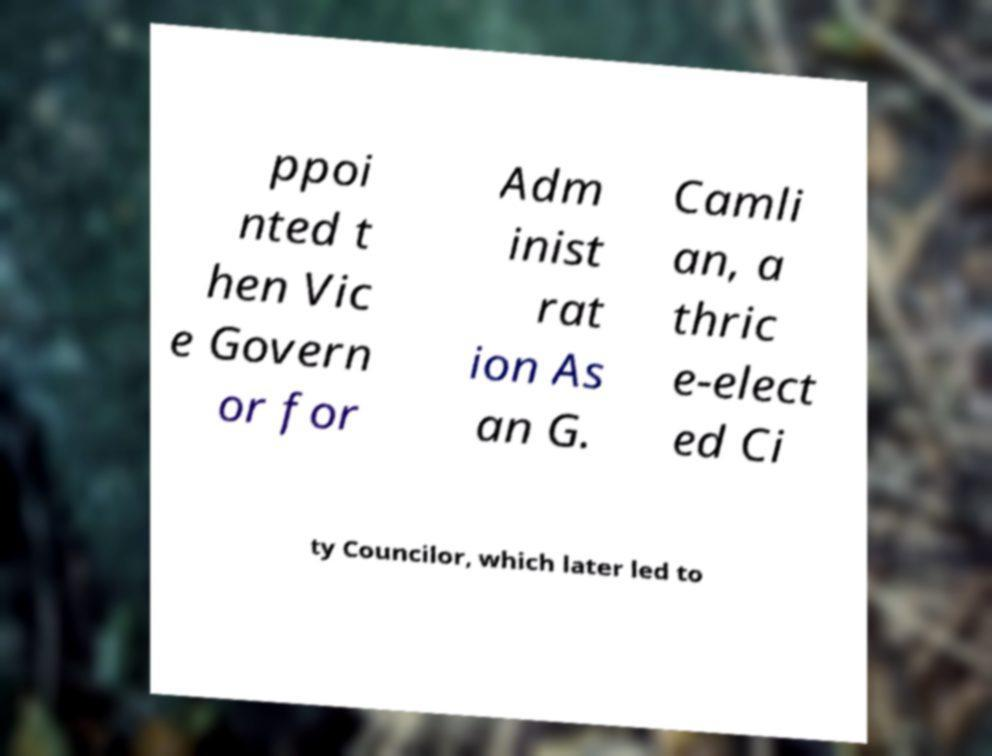There's text embedded in this image that I need extracted. Can you transcribe it verbatim? ppoi nted t hen Vic e Govern or for Adm inist rat ion As an G. Camli an, a thric e-elect ed Ci ty Councilor, which later led to 